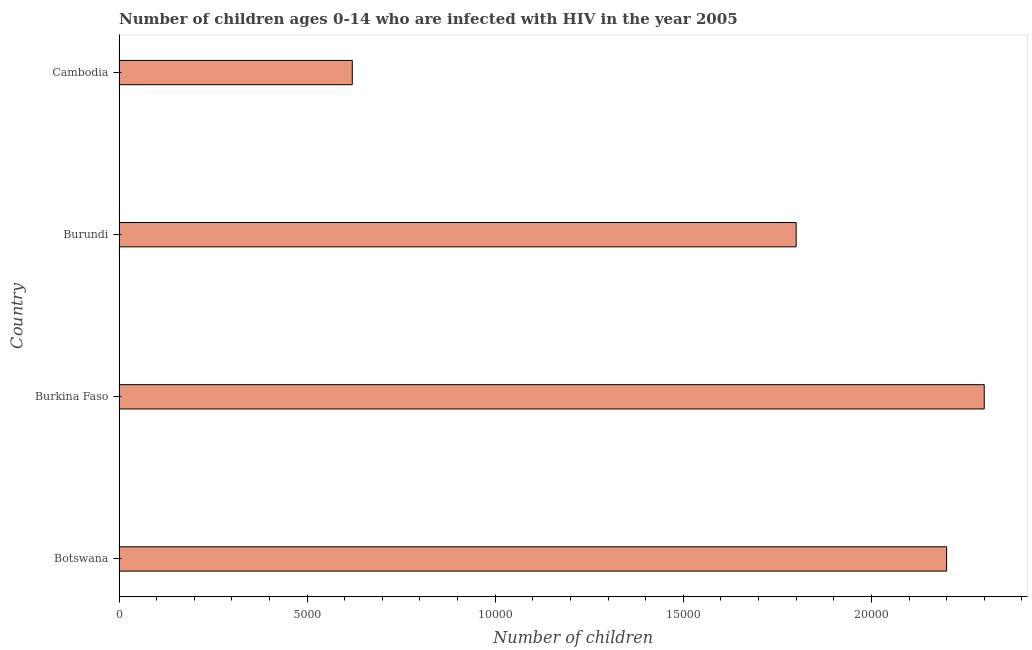Does the graph contain grids?
Your response must be concise. No. What is the title of the graph?
Provide a short and direct response. Number of children ages 0-14 who are infected with HIV in the year 2005. What is the label or title of the X-axis?
Provide a succinct answer. Number of children. What is the label or title of the Y-axis?
Your answer should be compact. Country. What is the number of children living with hiv in Burkina Faso?
Offer a terse response. 2.30e+04. Across all countries, what is the maximum number of children living with hiv?
Give a very brief answer. 2.30e+04. Across all countries, what is the minimum number of children living with hiv?
Give a very brief answer. 6200. In which country was the number of children living with hiv maximum?
Provide a short and direct response. Burkina Faso. In which country was the number of children living with hiv minimum?
Your answer should be compact. Cambodia. What is the sum of the number of children living with hiv?
Ensure brevity in your answer.  6.92e+04. What is the difference between the number of children living with hiv in Botswana and Burundi?
Offer a very short reply. 4000. What is the average number of children living with hiv per country?
Offer a terse response. 1.73e+04. What is the ratio of the number of children living with hiv in Burundi to that in Cambodia?
Your answer should be very brief. 2.9. Is the number of children living with hiv in Botswana less than that in Burundi?
Offer a terse response. No. Is the sum of the number of children living with hiv in Burkina Faso and Cambodia greater than the maximum number of children living with hiv across all countries?
Provide a short and direct response. Yes. What is the difference between the highest and the lowest number of children living with hiv?
Make the answer very short. 1.68e+04. In how many countries, is the number of children living with hiv greater than the average number of children living with hiv taken over all countries?
Give a very brief answer. 3. How many countries are there in the graph?
Ensure brevity in your answer.  4. What is the difference between two consecutive major ticks on the X-axis?
Keep it short and to the point. 5000. What is the Number of children in Botswana?
Provide a short and direct response. 2.20e+04. What is the Number of children of Burkina Faso?
Give a very brief answer. 2.30e+04. What is the Number of children in Burundi?
Provide a succinct answer. 1.80e+04. What is the Number of children of Cambodia?
Offer a terse response. 6200. What is the difference between the Number of children in Botswana and Burkina Faso?
Your response must be concise. -1000. What is the difference between the Number of children in Botswana and Burundi?
Ensure brevity in your answer.  4000. What is the difference between the Number of children in Botswana and Cambodia?
Make the answer very short. 1.58e+04. What is the difference between the Number of children in Burkina Faso and Burundi?
Make the answer very short. 5000. What is the difference between the Number of children in Burkina Faso and Cambodia?
Your answer should be very brief. 1.68e+04. What is the difference between the Number of children in Burundi and Cambodia?
Provide a short and direct response. 1.18e+04. What is the ratio of the Number of children in Botswana to that in Burundi?
Your answer should be compact. 1.22. What is the ratio of the Number of children in Botswana to that in Cambodia?
Your answer should be compact. 3.55. What is the ratio of the Number of children in Burkina Faso to that in Burundi?
Offer a terse response. 1.28. What is the ratio of the Number of children in Burkina Faso to that in Cambodia?
Make the answer very short. 3.71. What is the ratio of the Number of children in Burundi to that in Cambodia?
Offer a very short reply. 2.9. 